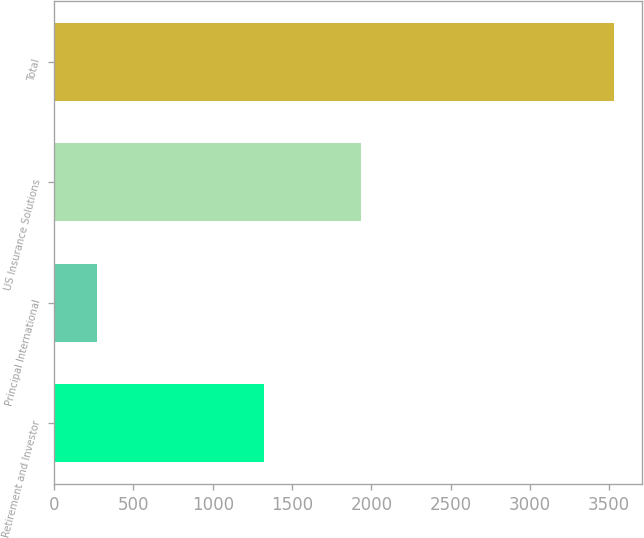Convert chart. <chart><loc_0><loc_0><loc_500><loc_500><bar_chart><fcel>Retirement and Investor<fcel>Principal International<fcel>US Insurance Solutions<fcel>Total<nl><fcel>1321.1<fcel>271<fcel>1937.7<fcel>3529.8<nl></chart> 